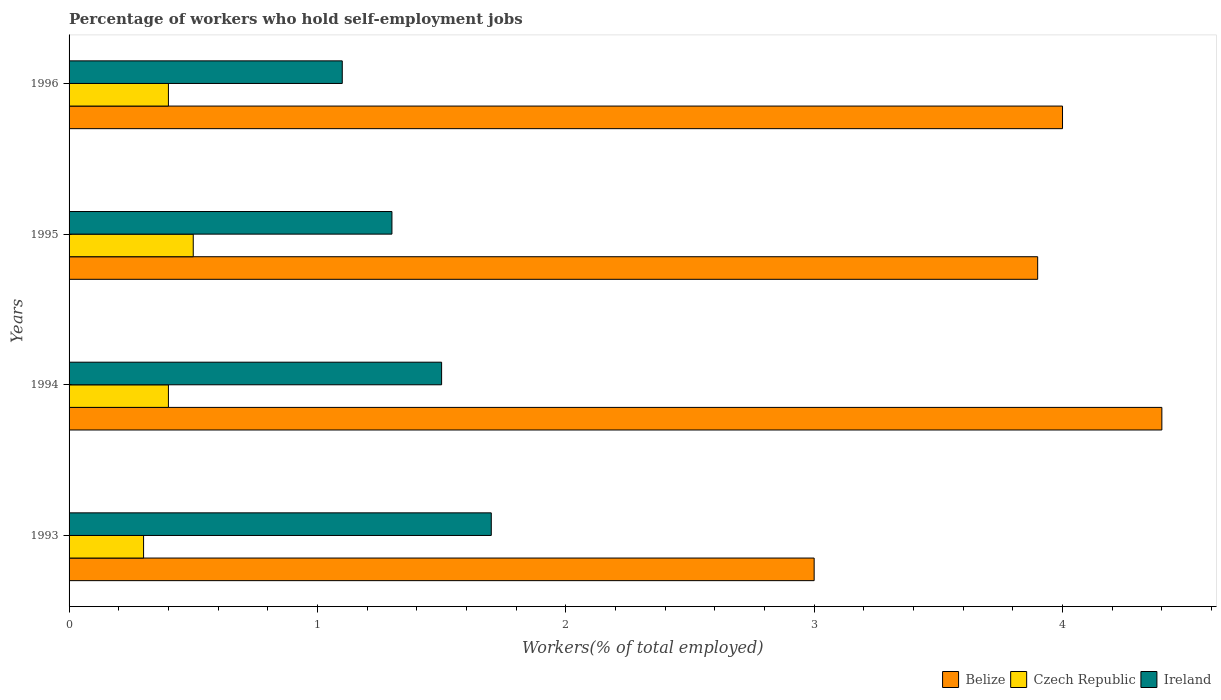Are the number of bars per tick equal to the number of legend labels?
Keep it short and to the point. Yes. Are the number of bars on each tick of the Y-axis equal?
Ensure brevity in your answer.  Yes. How many bars are there on the 2nd tick from the top?
Keep it short and to the point. 3. What is the label of the 4th group of bars from the top?
Give a very brief answer. 1993. In how many cases, is the number of bars for a given year not equal to the number of legend labels?
Keep it short and to the point. 0. Across all years, what is the maximum percentage of self-employed workers in Ireland?
Provide a succinct answer. 1.7. In which year was the percentage of self-employed workers in Belize maximum?
Ensure brevity in your answer.  1994. In which year was the percentage of self-employed workers in Czech Republic minimum?
Provide a short and direct response. 1993. What is the total percentage of self-employed workers in Ireland in the graph?
Offer a very short reply. 5.6. What is the difference between the percentage of self-employed workers in Belize in 1993 and that in 1996?
Offer a terse response. -1. What is the difference between the percentage of self-employed workers in Czech Republic in 1994 and the percentage of self-employed workers in Belize in 1996?
Keep it short and to the point. -3.6. What is the average percentage of self-employed workers in Czech Republic per year?
Keep it short and to the point. 0.4. In the year 1995, what is the difference between the percentage of self-employed workers in Czech Republic and percentage of self-employed workers in Ireland?
Give a very brief answer. -0.8. In how many years, is the percentage of self-employed workers in Ireland greater than 1.4 %?
Keep it short and to the point. 2. What is the ratio of the percentage of self-employed workers in Czech Republic in 1995 to that in 1996?
Your answer should be compact. 1.25. Is the difference between the percentage of self-employed workers in Czech Republic in 1993 and 1996 greater than the difference between the percentage of self-employed workers in Ireland in 1993 and 1996?
Offer a very short reply. No. What is the difference between the highest and the second highest percentage of self-employed workers in Ireland?
Offer a terse response. 0.2. What is the difference between the highest and the lowest percentage of self-employed workers in Ireland?
Provide a short and direct response. 0.6. In how many years, is the percentage of self-employed workers in Czech Republic greater than the average percentage of self-employed workers in Czech Republic taken over all years?
Offer a terse response. 1. Is the sum of the percentage of self-employed workers in Ireland in 1994 and 1996 greater than the maximum percentage of self-employed workers in Belize across all years?
Offer a terse response. No. What does the 3rd bar from the top in 1995 represents?
Offer a very short reply. Belize. What does the 3rd bar from the bottom in 1995 represents?
Make the answer very short. Ireland. How many bars are there?
Provide a succinct answer. 12. How many years are there in the graph?
Provide a succinct answer. 4. What is the difference between two consecutive major ticks on the X-axis?
Offer a very short reply. 1. Does the graph contain any zero values?
Your response must be concise. No. Does the graph contain grids?
Give a very brief answer. No. Where does the legend appear in the graph?
Ensure brevity in your answer.  Bottom right. What is the title of the graph?
Your response must be concise. Percentage of workers who hold self-employment jobs. Does "Upper middle income" appear as one of the legend labels in the graph?
Provide a short and direct response. No. What is the label or title of the X-axis?
Ensure brevity in your answer.  Workers(% of total employed). What is the label or title of the Y-axis?
Ensure brevity in your answer.  Years. What is the Workers(% of total employed) in Belize in 1993?
Offer a terse response. 3. What is the Workers(% of total employed) of Czech Republic in 1993?
Make the answer very short. 0.3. What is the Workers(% of total employed) of Ireland in 1993?
Make the answer very short. 1.7. What is the Workers(% of total employed) of Belize in 1994?
Provide a short and direct response. 4.4. What is the Workers(% of total employed) in Czech Republic in 1994?
Offer a terse response. 0.4. What is the Workers(% of total employed) in Ireland in 1994?
Give a very brief answer. 1.5. What is the Workers(% of total employed) in Belize in 1995?
Your answer should be very brief. 3.9. What is the Workers(% of total employed) in Ireland in 1995?
Offer a very short reply. 1.3. What is the Workers(% of total employed) in Czech Republic in 1996?
Ensure brevity in your answer.  0.4. What is the Workers(% of total employed) of Ireland in 1996?
Provide a succinct answer. 1.1. Across all years, what is the maximum Workers(% of total employed) in Belize?
Your answer should be compact. 4.4. Across all years, what is the maximum Workers(% of total employed) of Ireland?
Offer a terse response. 1.7. Across all years, what is the minimum Workers(% of total employed) in Belize?
Ensure brevity in your answer.  3. Across all years, what is the minimum Workers(% of total employed) of Czech Republic?
Your answer should be very brief. 0.3. Across all years, what is the minimum Workers(% of total employed) of Ireland?
Offer a terse response. 1.1. What is the total Workers(% of total employed) of Belize in the graph?
Give a very brief answer. 15.3. What is the total Workers(% of total employed) of Ireland in the graph?
Your response must be concise. 5.6. What is the difference between the Workers(% of total employed) in Ireland in 1993 and that in 1994?
Offer a very short reply. 0.2. What is the difference between the Workers(% of total employed) in Belize in 1993 and that in 1995?
Provide a short and direct response. -0.9. What is the difference between the Workers(% of total employed) of Czech Republic in 1993 and that in 1995?
Your answer should be compact. -0.2. What is the difference between the Workers(% of total employed) of Ireland in 1993 and that in 1995?
Offer a very short reply. 0.4. What is the difference between the Workers(% of total employed) of Belize in 1993 and that in 1996?
Give a very brief answer. -1. What is the difference between the Workers(% of total employed) in Czech Republic in 1993 and that in 1996?
Offer a very short reply. -0.1. What is the difference between the Workers(% of total employed) of Czech Republic in 1994 and that in 1995?
Give a very brief answer. -0.1. What is the difference between the Workers(% of total employed) of Ireland in 1994 and that in 1995?
Your response must be concise. 0.2. What is the difference between the Workers(% of total employed) of Czech Republic in 1994 and that in 1996?
Give a very brief answer. 0. What is the difference between the Workers(% of total employed) in Belize in 1995 and that in 1996?
Provide a short and direct response. -0.1. What is the difference between the Workers(% of total employed) of Ireland in 1995 and that in 1996?
Offer a terse response. 0.2. What is the difference between the Workers(% of total employed) in Belize in 1993 and the Workers(% of total employed) in Ireland in 1994?
Provide a short and direct response. 1.5. What is the difference between the Workers(% of total employed) in Czech Republic in 1993 and the Workers(% of total employed) in Ireland in 1994?
Provide a succinct answer. -1.2. What is the difference between the Workers(% of total employed) of Belize in 1993 and the Workers(% of total employed) of Czech Republic in 1995?
Ensure brevity in your answer.  2.5. What is the difference between the Workers(% of total employed) in Belize in 1993 and the Workers(% of total employed) in Ireland in 1995?
Your answer should be very brief. 1.7. What is the difference between the Workers(% of total employed) of Belize in 1993 and the Workers(% of total employed) of Czech Republic in 1996?
Make the answer very short. 2.6. What is the difference between the Workers(% of total employed) in Belize in 1993 and the Workers(% of total employed) in Ireland in 1996?
Offer a very short reply. 1.9. What is the difference between the Workers(% of total employed) of Czech Republic in 1993 and the Workers(% of total employed) of Ireland in 1996?
Provide a succinct answer. -0.8. What is the difference between the Workers(% of total employed) in Belize in 1994 and the Workers(% of total employed) in Czech Republic in 1995?
Your response must be concise. 3.9. What is the difference between the Workers(% of total employed) of Belize in 1995 and the Workers(% of total employed) of Czech Republic in 1996?
Provide a short and direct response. 3.5. What is the average Workers(% of total employed) in Belize per year?
Your answer should be very brief. 3.83. What is the average Workers(% of total employed) in Czech Republic per year?
Give a very brief answer. 0.4. In the year 1993, what is the difference between the Workers(% of total employed) of Belize and Workers(% of total employed) of Czech Republic?
Your answer should be compact. 2.7. In the year 1993, what is the difference between the Workers(% of total employed) of Czech Republic and Workers(% of total employed) of Ireland?
Make the answer very short. -1.4. In the year 1994, what is the difference between the Workers(% of total employed) of Belize and Workers(% of total employed) of Ireland?
Your answer should be very brief. 2.9. In the year 1995, what is the difference between the Workers(% of total employed) of Belize and Workers(% of total employed) of Czech Republic?
Provide a succinct answer. 3.4. In the year 1995, what is the difference between the Workers(% of total employed) of Czech Republic and Workers(% of total employed) of Ireland?
Provide a short and direct response. -0.8. In the year 1996, what is the difference between the Workers(% of total employed) of Belize and Workers(% of total employed) of Czech Republic?
Your answer should be very brief. 3.6. What is the ratio of the Workers(% of total employed) of Belize in 1993 to that in 1994?
Your answer should be very brief. 0.68. What is the ratio of the Workers(% of total employed) in Ireland in 1993 to that in 1994?
Make the answer very short. 1.13. What is the ratio of the Workers(% of total employed) in Belize in 1993 to that in 1995?
Your answer should be compact. 0.77. What is the ratio of the Workers(% of total employed) in Ireland in 1993 to that in 1995?
Make the answer very short. 1.31. What is the ratio of the Workers(% of total employed) in Belize in 1993 to that in 1996?
Give a very brief answer. 0.75. What is the ratio of the Workers(% of total employed) in Czech Republic in 1993 to that in 1996?
Your response must be concise. 0.75. What is the ratio of the Workers(% of total employed) of Ireland in 1993 to that in 1996?
Offer a very short reply. 1.55. What is the ratio of the Workers(% of total employed) of Belize in 1994 to that in 1995?
Ensure brevity in your answer.  1.13. What is the ratio of the Workers(% of total employed) in Czech Republic in 1994 to that in 1995?
Your answer should be very brief. 0.8. What is the ratio of the Workers(% of total employed) of Ireland in 1994 to that in 1995?
Ensure brevity in your answer.  1.15. What is the ratio of the Workers(% of total employed) of Belize in 1994 to that in 1996?
Provide a succinct answer. 1.1. What is the ratio of the Workers(% of total employed) of Ireland in 1994 to that in 1996?
Keep it short and to the point. 1.36. What is the ratio of the Workers(% of total employed) in Belize in 1995 to that in 1996?
Provide a short and direct response. 0.97. What is the ratio of the Workers(% of total employed) of Czech Republic in 1995 to that in 1996?
Provide a succinct answer. 1.25. What is the ratio of the Workers(% of total employed) in Ireland in 1995 to that in 1996?
Ensure brevity in your answer.  1.18. What is the difference between the highest and the second highest Workers(% of total employed) of Czech Republic?
Offer a very short reply. 0.1. 